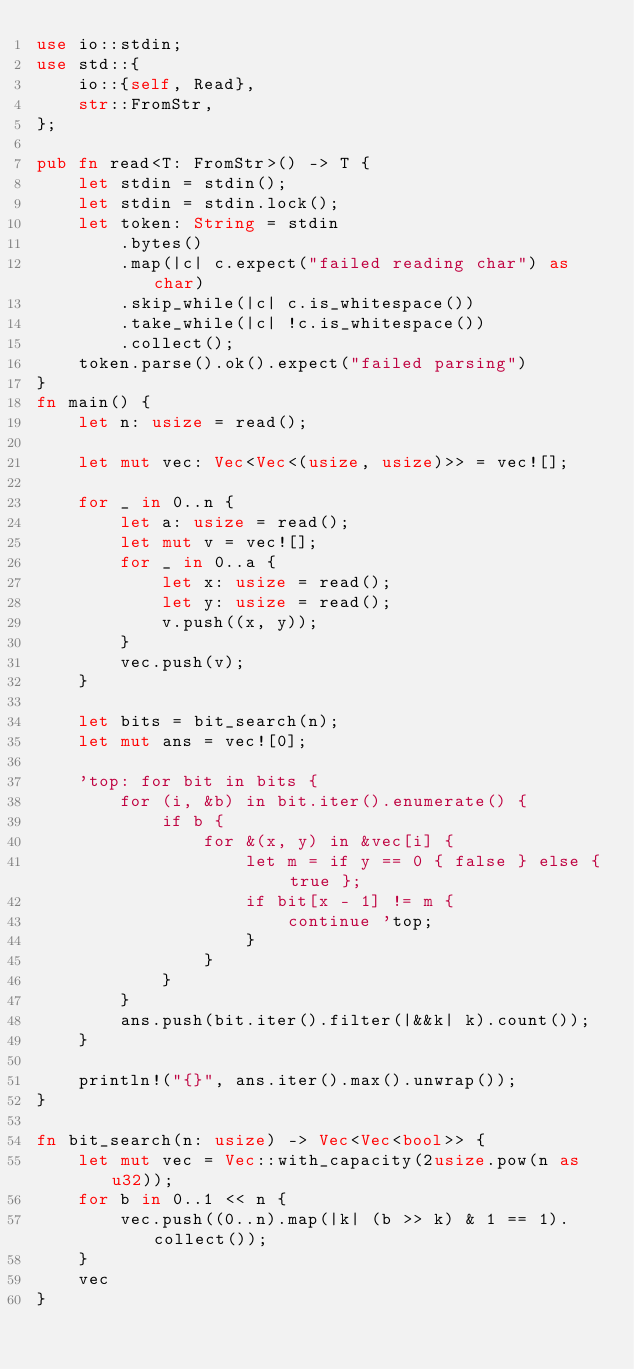<code> <loc_0><loc_0><loc_500><loc_500><_Rust_>use io::stdin;
use std::{
    io::{self, Read},
    str::FromStr,
};

pub fn read<T: FromStr>() -> T {
    let stdin = stdin();
    let stdin = stdin.lock();
    let token: String = stdin
        .bytes()
        .map(|c| c.expect("failed reading char") as char)
        .skip_while(|c| c.is_whitespace())
        .take_while(|c| !c.is_whitespace())
        .collect();
    token.parse().ok().expect("failed parsing")
}
fn main() {
    let n: usize = read();

    let mut vec: Vec<Vec<(usize, usize)>> = vec![];

    for _ in 0..n {
        let a: usize = read();
        let mut v = vec![];
        for _ in 0..a {
            let x: usize = read();
            let y: usize = read();
            v.push((x, y));
        }
        vec.push(v);
    }

    let bits = bit_search(n);
    let mut ans = vec![0];

    'top: for bit in bits {
        for (i, &b) in bit.iter().enumerate() {
            if b {
                for &(x, y) in &vec[i] {
                    let m = if y == 0 { false } else { true };
                    if bit[x - 1] != m {
                        continue 'top;
                    }
                }
            }
        }
        ans.push(bit.iter().filter(|&&k| k).count());
    }

    println!("{}", ans.iter().max().unwrap());
}

fn bit_search(n: usize) -> Vec<Vec<bool>> {
    let mut vec = Vec::with_capacity(2usize.pow(n as u32));
    for b in 0..1 << n {
        vec.push((0..n).map(|k| (b >> k) & 1 == 1).collect());
    }
    vec
}
</code> 